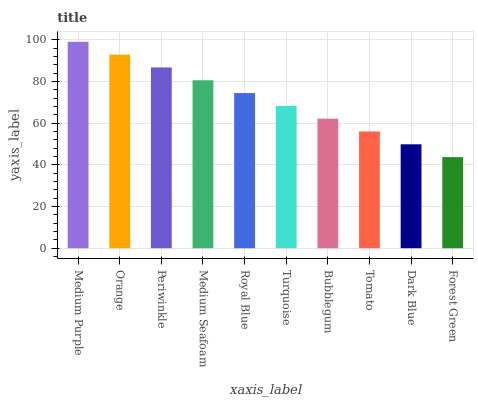Is Forest Green the minimum?
Answer yes or no. Yes. Is Medium Purple the maximum?
Answer yes or no. Yes. Is Orange the minimum?
Answer yes or no. No. Is Orange the maximum?
Answer yes or no. No. Is Medium Purple greater than Orange?
Answer yes or no. Yes. Is Orange less than Medium Purple?
Answer yes or no. Yes. Is Orange greater than Medium Purple?
Answer yes or no. No. Is Medium Purple less than Orange?
Answer yes or no. No. Is Royal Blue the high median?
Answer yes or no. Yes. Is Turquoise the low median?
Answer yes or no. Yes. Is Medium Purple the high median?
Answer yes or no. No. Is Medium Purple the low median?
Answer yes or no. No. 